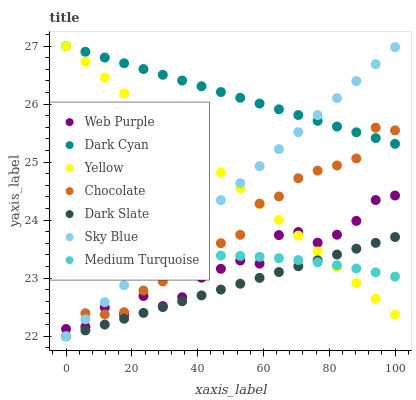Does Dark Slate have the minimum area under the curve?
Answer yes or no. Yes. Does Dark Cyan have the maximum area under the curve?
Answer yes or no. Yes. Does Chocolate have the minimum area under the curve?
Answer yes or no. No. Does Chocolate have the maximum area under the curve?
Answer yes or no. No. Is Dark Slate the smoothest?
Answer yes or no. Yes. Is Web Purple the roughest?
Answer yes or no. Yes. Is Chocolate the smoothest?
Answer yes or no. No. Is Chocolate the roughest?
Answer yes or no. No. Does Chocolate have the lowest value?
Answer yes or no. Yes. Does Web Purple have the lowest value?
Answer yes or no. No. Does Dark Cyan have the highest value?
Answer yes or no. Yes. Does Chocolate have the highest value?
Answer yes or no. No. Is Dark Slate less than Dark Cyan?
Answer yes or no. Yes. Is Dark Cyan greater than Medium Turquoise?
Answer yes or no. Yes. Does Web Purple intersect Chocolate?
Answer yes or no. Yes. Is Web Purple less than Chocolate?
Answer yes or no. No. Is Web Purple greater than Chocolate?
Answer yes or no. No. Does Dark Slate intersect Dark Cyan?
Answer yes or no. No. 